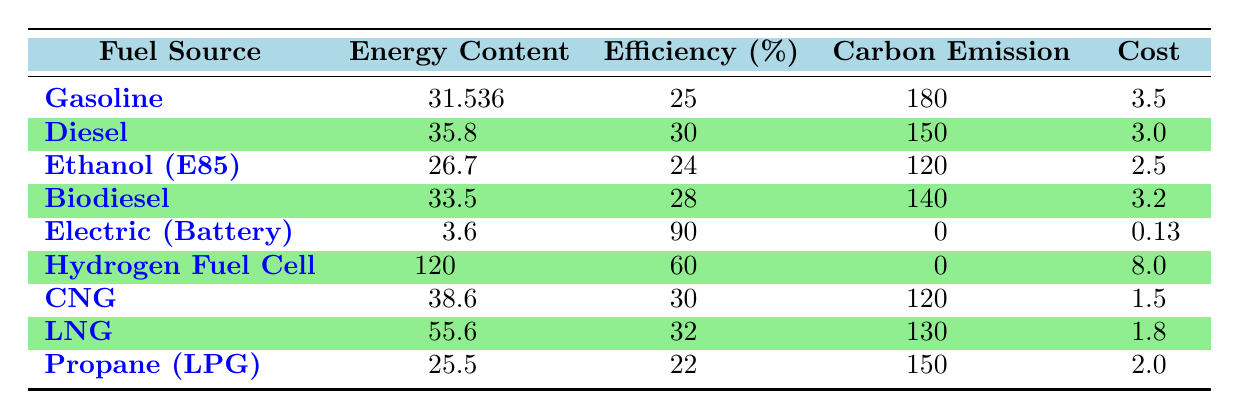What's the energy content of Biodiesel? The table lists the energy content of Biodiesel, which is stated as 33.5 MJ per liter.
Answer: 33.5 MJ per liter Which fuel source has the highest efficiency percentage? By examining the efficiency percentages in the table, Electric (Battery) has the highest efficiency at 90%.
Answer: 90% What is the carbon emission of Ethanol (E85)? The table indicates that Ethanol (E85) has a carbon emission of 120 grams per kilometer.
Answer: 120 grams per kilometer Which alternative fuel has the lowest cost per unit? Analyzing the costs per unit in the table, Electric (Battery) costs 0.13 USD per kilowatt-hour, which is the lowest.
Answer: 0.13 USD per kilowatt-hour Is the carbon emission of Hydrogen Fuel Cell the same as that of Electric (Battery)? Both Hydrogen Fuel Cell and Electric (Battery) have a carbon emission of 0 grams per kilometer, confirming they are the same in this regard.
Answer: Yes What is the average efficiency percentage of Diesel and Biodiesel combined? The efficiency percentages of Diesel (30%) and Biodiesel (28%) can be averaged: (30 + 28) / 2 = 29%.
Answer: 29% What is the difference in carbon emissions between Diesel and Propane (LPG)? The carbon emission for Diesel is 150 grams per kilometer, while for Propane (LPG) it is also 150 grams. The difference is calculated as 150 - 150 = 0.
Answer: 0 grams per kilometer Which fuel source offers the best balance between cost and efficiency? Complex reasoning is required: Electric (Battery) has high efficiency (90%) but higher cost (0.13). Diesel has an efficiency of 30% and a cost of 3.0. Analyzing the cost efficiency ratio for all fuels would provide the best balance.
Answer: Electric (Battery) If you were to choose among fuels with carbon emissions of 120 g/km, which has the best efficiency percentage? The fuels with 120 g/km emissions are Ethanol (E85) with 24% efficiency and CNG with 30% efficiency. CNG has the higher efficiency percentage.
Answer: CNG How much more expensive is Hydrogen Fuel Cell compared to Compressed Natural Gas (CNG)? The Hydrogen Fuel Cell costs 8.0 USD per kilogram and CNG costs 1.5 USD per cubic meter. The difference is calculated as 8.0 - 1.5 = 6.5 USD.
Answer: 6.5 USD 